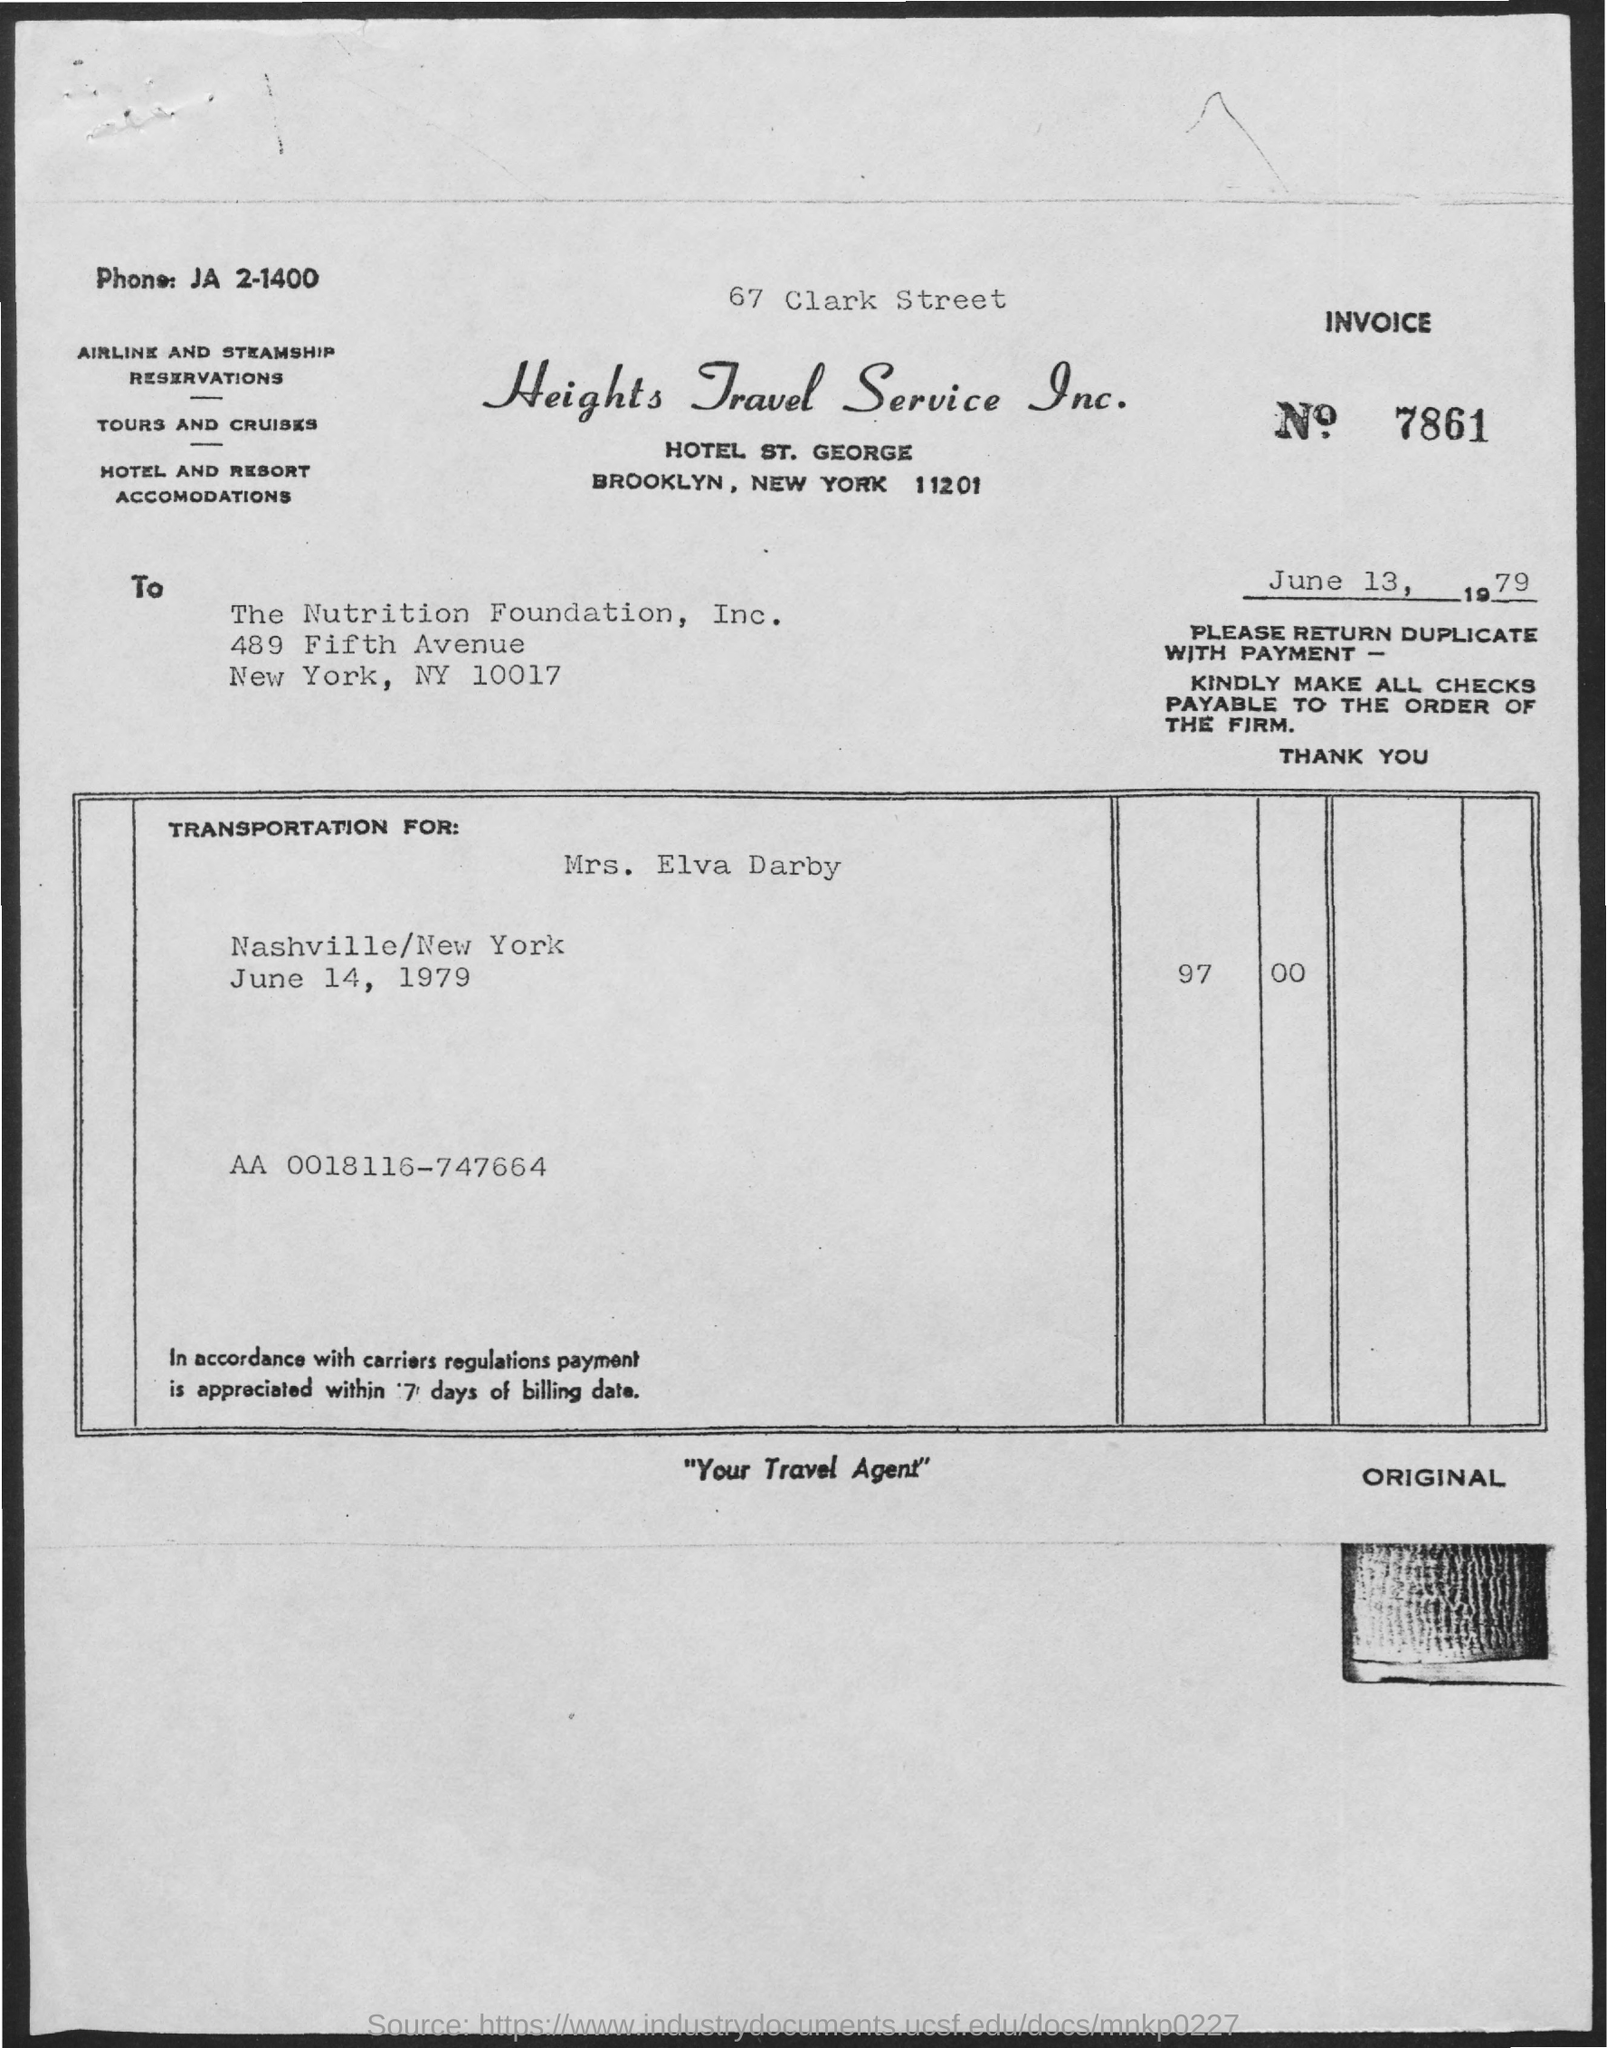Mention a couple of crucial points in this snapshot. The date on the document is June 13, 1979. The total amount is 97,000. The Invoice No. is 7861... 